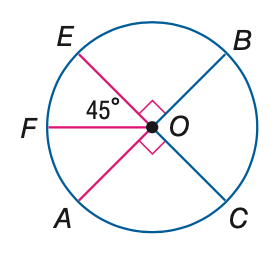Answer the mathemtical geometry problem and directly provide the correct option letter.
Question: E C and A B are diameters of \odot O. Find its measure of \widehat E B.
Choices: A: 45 B: 90 C: 180 D: 270 B 